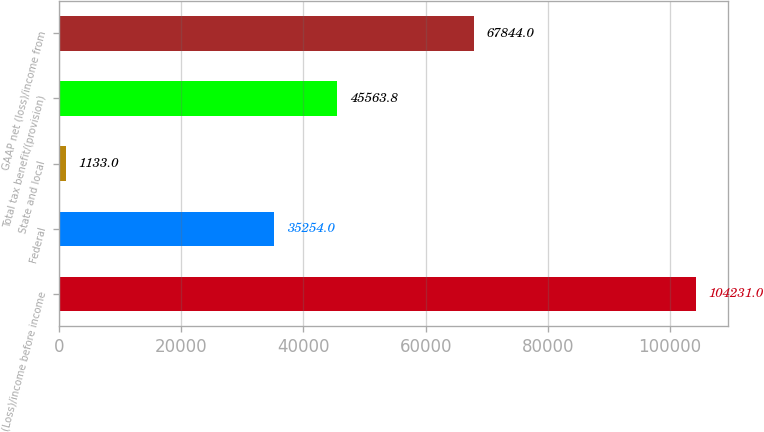<chart> <loc_0><loc_0><loc_500><loc_500><bar_chart><fcel>(Loss)/income before income<fcel>Federal<fcel>State and local<fcel>Total tax benefit/(provision)<fcel>GAAP net (loss)/income from<nl><fcel>104231<fcel>35254<fcel>1133<fcel>45563.8<fcel>67844<nl></chart> 